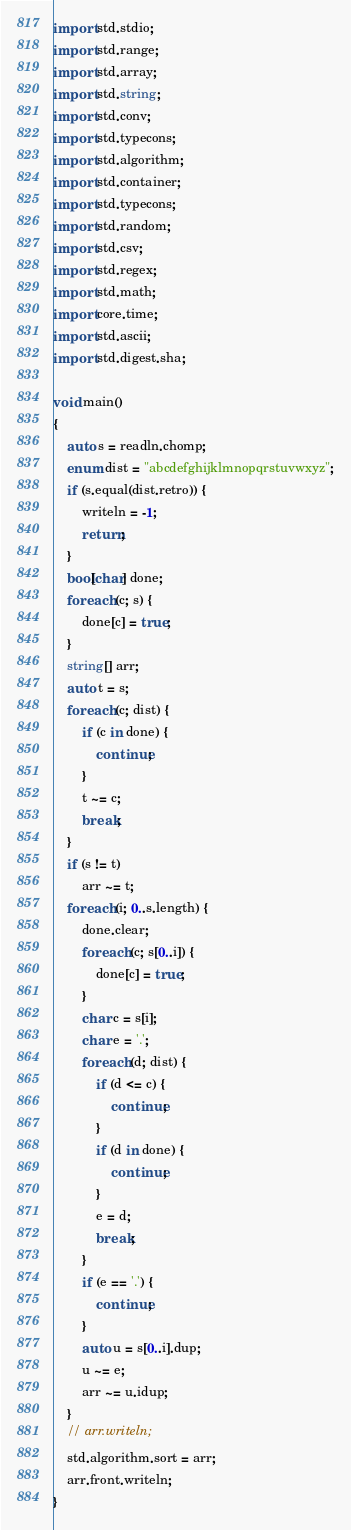Convert code to text. <code><loc_0><loc_0><loc_500><loc_500><_D_>import std.stdio;
import std.range;
import std.array;
import std.string;
import std.conv;
import std.typecons;
import std.algorithm;
import std.container;
import std.typecons;
import std.random;
import std.csv;
import std.regex;
import std.math;
import core.time;
import std.ascii;
import std.digest.sha;

void main()
{
	auto s = readln.chomp;
	enum dist = "abcdefghijklmnopqrstuvwxyz";
	if (s.equal(dist.retro)) {
		writeln = -1;
		return;
	}
	bool[char] done;
	foreach (c; s) {
		done[c] = true;
	}
	string[] arr;
	auto t = s;
	foreach (c; dist) {
		if (c in done) {
			continue;
		}
		t ~= c;
		break;
	}
	if (s != t)
		arr ~= t;
	foreach (i; 0..s.length) {
		done.clear;
		foreach (c; s[0..i]) {
			done[c] = true;
		}
		char c = s[i];
		char e = '.';
		foreach (d; dist) {
			if (d <= c) {
				continue;
			}
			if (d in done) {
				continue;
			}
			e = d;
			break;
		}
		if (e == '.') {
			continue;
		}
		auto u = s[0..i].dup;
		u ~= e;
		arr ~= u.idup;
	}
	// arr.writeln;
	std.algorithm.sort = arr;
	arr.front.writeln;
}
</code> 